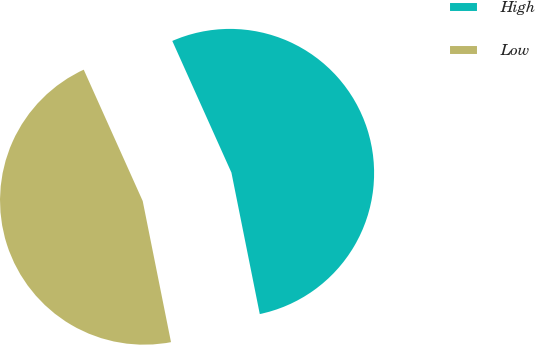Convert chart. <chart><loc_0><loc_0><loc_500><loc_500><pie_chart><fcel>High<fcel>Low<nl><fcel>53.57%<fcel>46.43%<nl></chart> 